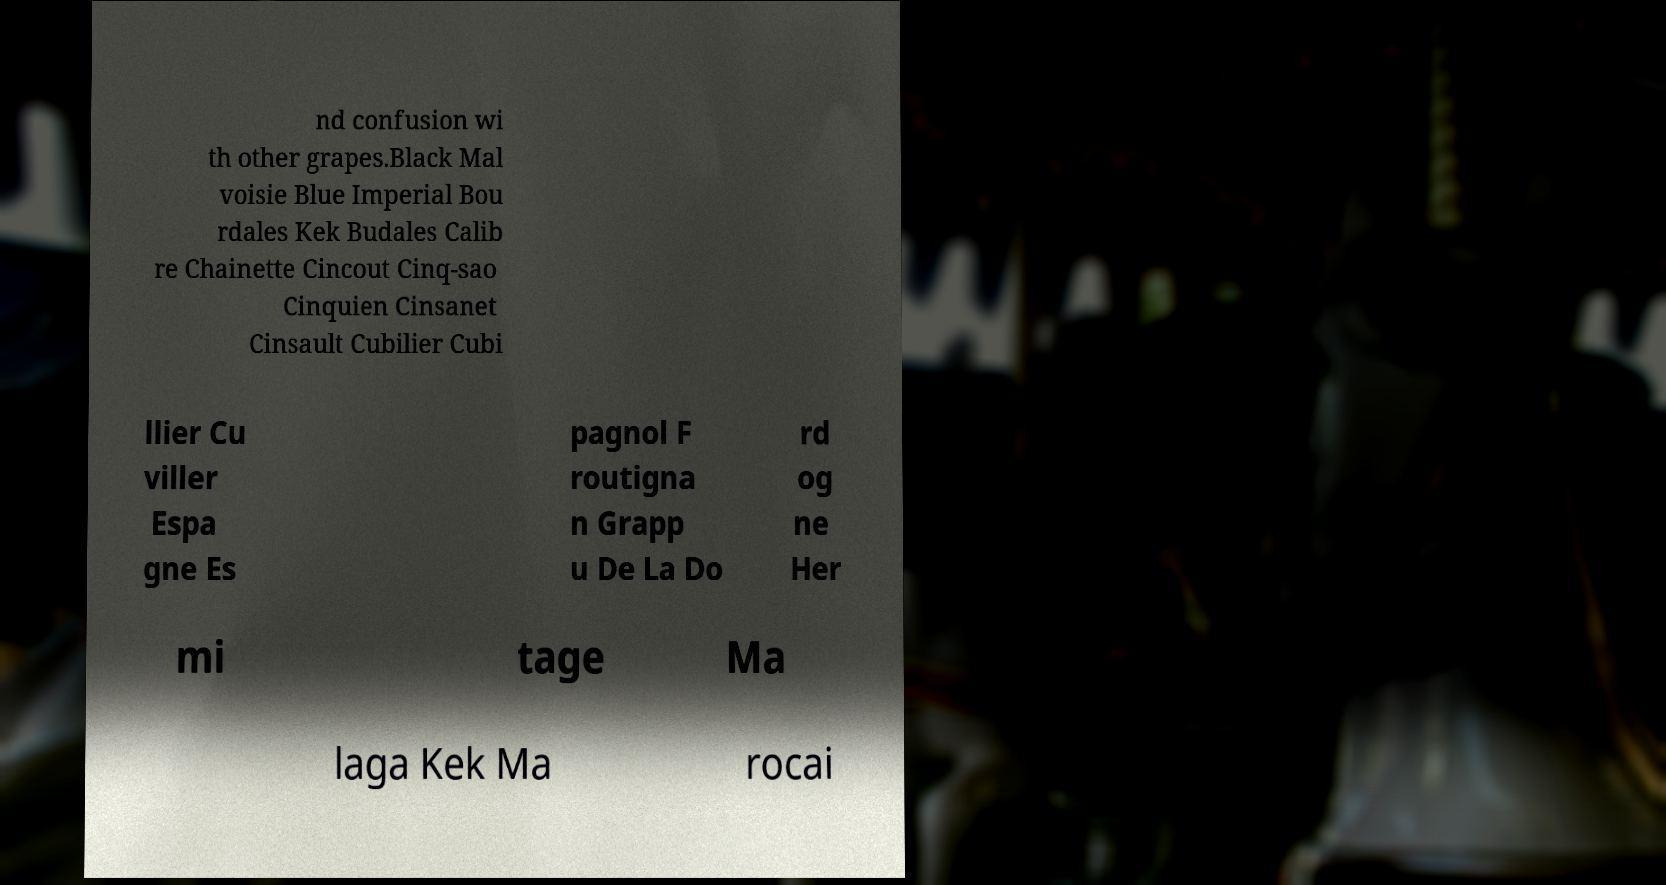Please read and relay the text visible in this image. What does it say? nd confusion wi th other grapes.Black Mal voisie Blue Imperial Bou rdales Kek Budales Calib re Chainette Cincout Cinq-sao Cinquien Cinsanet Cinsault Cubilier Cubi llier Cu viller Espa gne Es pagnol F routigna n Grapp u De La Do rd og ne Her mi tage Ma laga Kek Ma rocai 